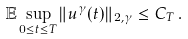<formula> <loc_0><loc_0><loc_500><loc_500>\mathbb { E } \sup _ { 0 \leq t \leq T } \| u ^ { \gamma } ( t ) \| _ { 2 , \gamma } \leq C _ { T } \, .</formula> 